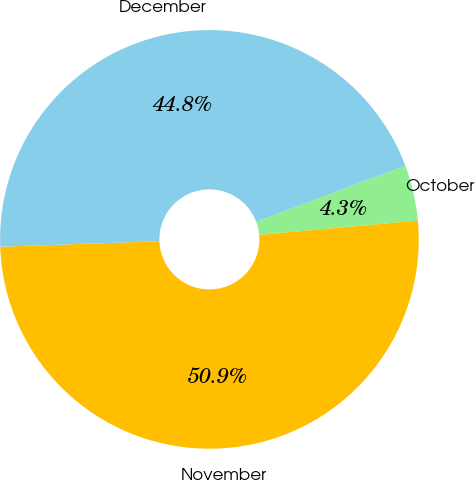Convert chart to OTSL. <chart><loc_0><loc_0><loc_500><loc_500><pie_chart><fcel>October<fcel>November<fcel>December<nl><fcel>4.3%<fcel>50.87%<fcel>44.83%<nl></chart> 